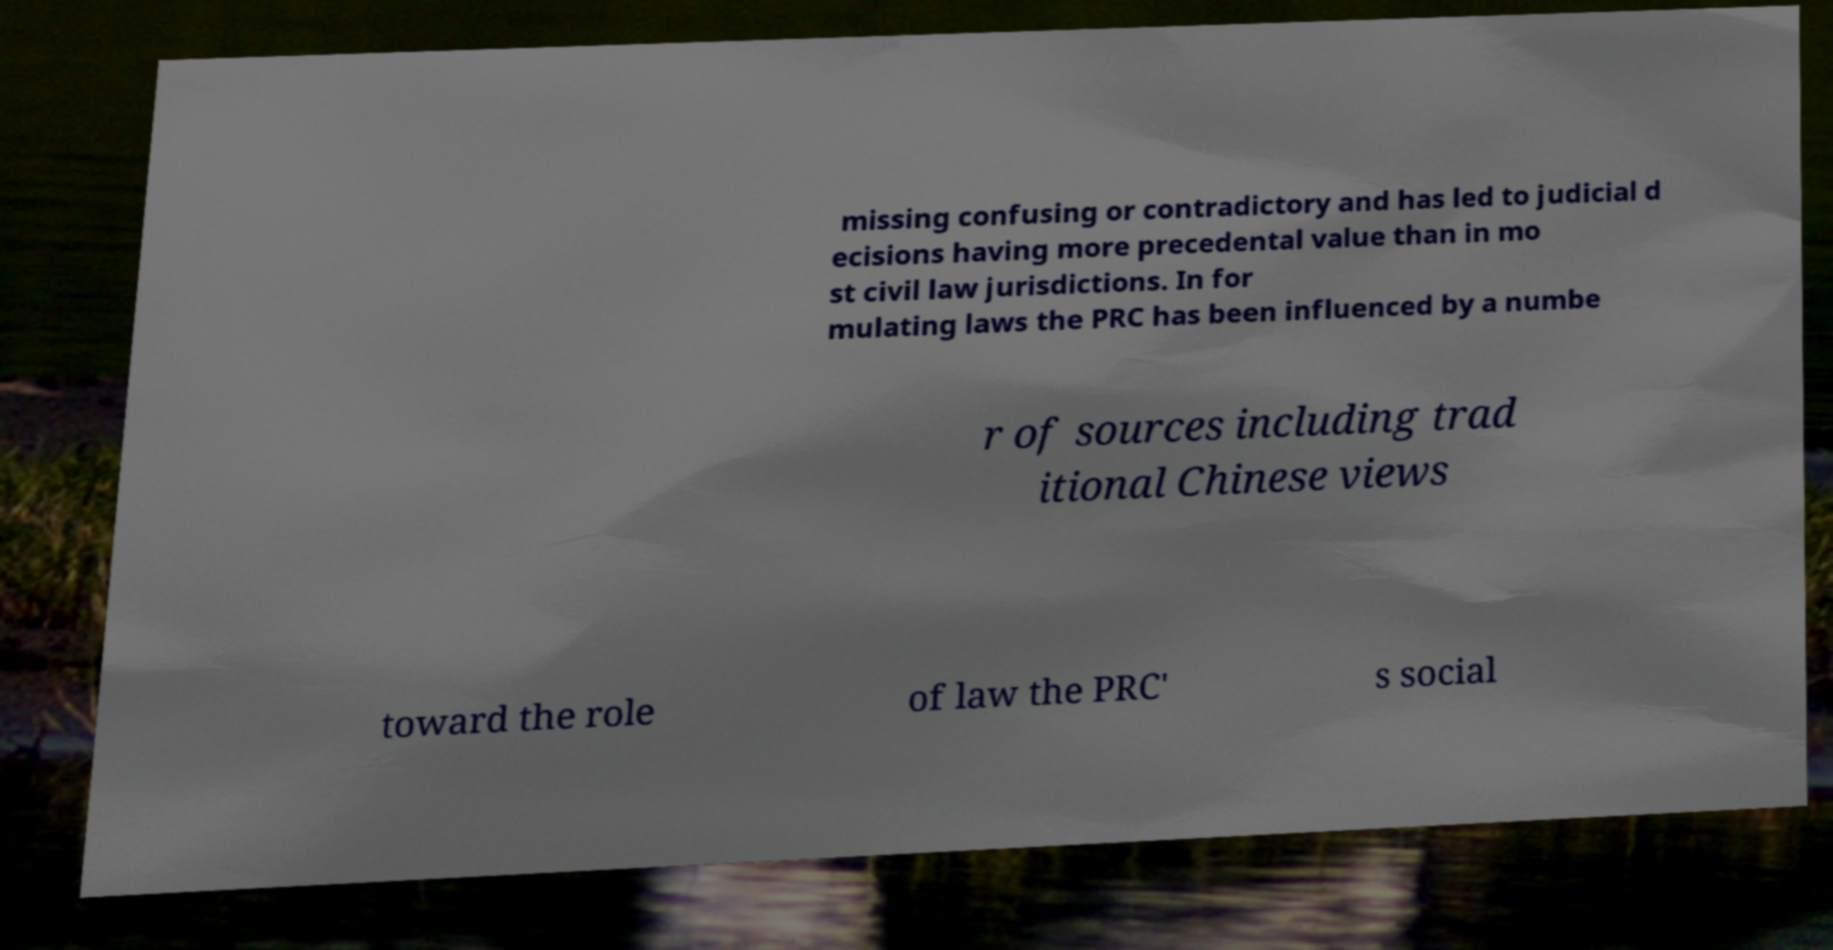Can you accurately transcribe the text from the provided image for me? missing confusing or contradictory and has led to judicial d ecisions having more precedental value than in mo st civil law jurisdictions. In for mulating laws the PRC has been influenced by a numbe r of sources including trad itional Chinese views toward the role of law the PRC' s social 